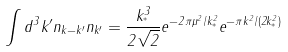<formula> <loc_0><loc_0><loc_500><loc_500>\int d ^ { 3 } k ^ { \prime } n _ { k - k ^ { \prime } } n _ { k ^ { \prime } } = \frac { k _ { ^ { * } } ^ { 3 } } { 2 \sqrt { 2 } } e ^ { - 2 \pi \mu ^ { 2 } / k _ { ^ { * } } ^ { 2 } } e ^ { - \pi k ^ { 2 } / ( 2 k _ { ^ { * } } ^ { 2 } ) }</formula> 